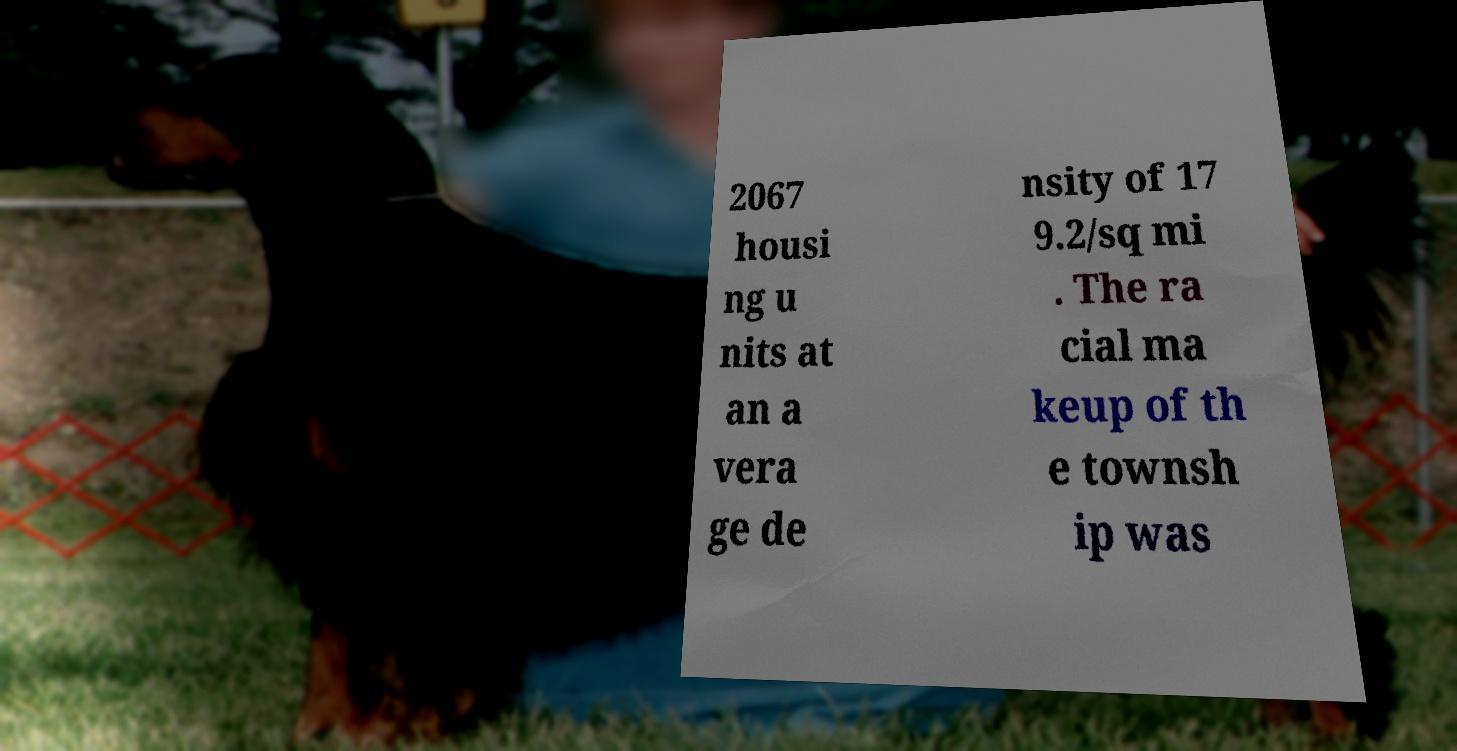Can you accurately transcribe the text from the provided image for me? 2067 housi ng u nits at an a vera ge de nsity of 17 9.2/sq mi . The ra cial ma keup of th e townsh ip was 